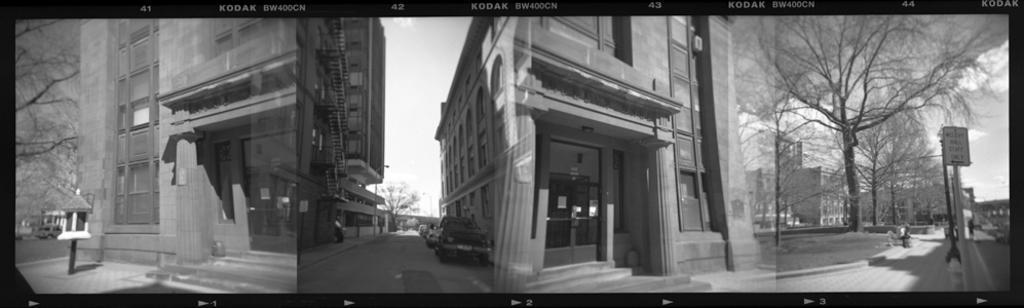In one or two sentences, can you explain what this image depicts? There are three images. In the first image, there is a pole on the footpath, near a building which is having glass door and windows. In the background, there is a vehicle on the road, near building, there are trees and there is sky. In the second image, there are vehicles on the road. On both sides of the road, there are buildings. In the background, there are trees and there is sky. In the third image, on the left side, there are trees and grass on the ground, near a footpath, on which, there are poles, which is near a road, on which, there is a person. In the background, there are buildings and clouds in the sky. 